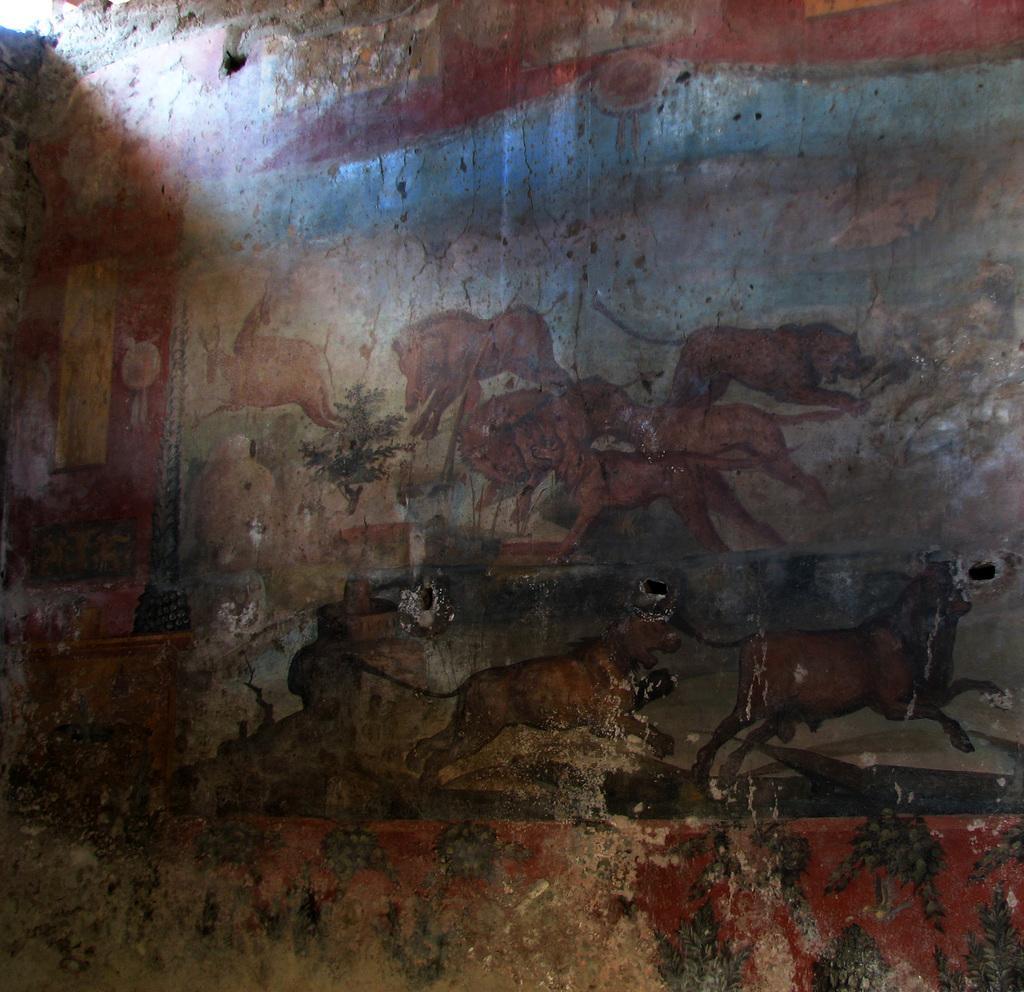How would you summarize this image in a sentence or two? On the top left, there is a light. In this image, we can see there is a painting on a wall. In this painting, there are animals, trees and other objects. 